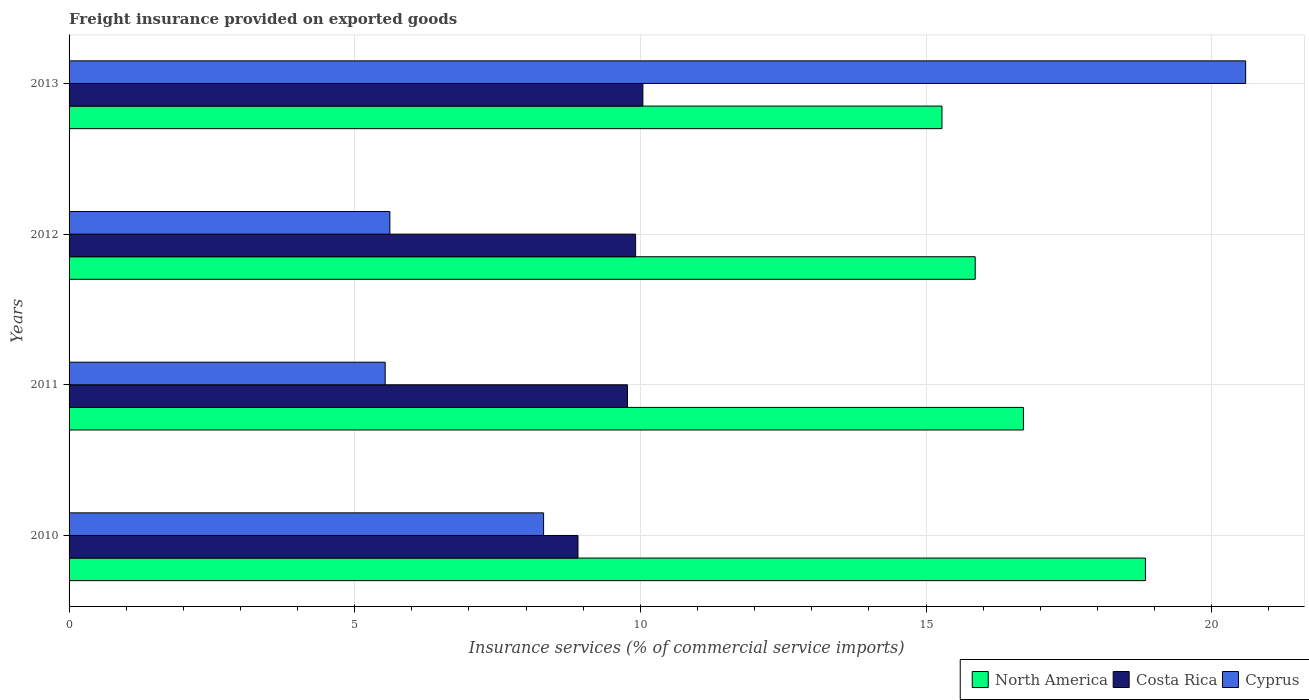How many different coloured bars are there?
Your answer should be compact. 3. How many groups of bars are there?
Provide a short and direct response. 4. How many bars are there on the 2nd tick from the top?
Provide a succinct answer. 3. How many bars are there on the 2nd tick from the bottom?
Ensure brevity in your answer.  3. What is the label of the 1st group of bars from the top?
Offer a very short reply. 2013. In how many cases, is the number of bars for a given year not equal to the number of legend labels?
Provide a succinct answer. 0. What is the freight insurance provided on exported goods in Costa Rica in 2012?
Give a very brief answer. 9.92. Across all years, what is the maximum freight insurance provided on exported goods in North America?
Keep it short and to the point. 18.84. Across all years, what is the minimum freight insurance provided on exported goods in Costa Rica?
Your response must be concise. 8.91. In which year was the freight insurance provided on exported goods in North America minimum?
Ensure brevity in your answer.  2013. What is the total freight insurance provided on exported goods in Cyprus in the graph?
Your answer should be very brief. 40.05. What is the difference between the freight insurance provided on exported goods in North America in 2010 and that in 2013?
Provide a succinct answer. 3.56. What is the difference between the freight insurance provided on exported goods in North America in 2011 and the freight insurance provided on exported goods in Cyprus in 2013?
Provide a short and direct response. -3.89. What is the average freight insurance provided on exported goods in Cyprus per year?
Your response must be concise. 10.01. In the year 2010, what is the difference between the freight insurance provided on exported goods in Costa Rica and freight insurance provided on exported goods in North America?
Your response must be concise. -9.93. What is the ratio of the freight insurance provided on exported goods in Costa Rica in 2011 to that in 2013?
Provide a short and direct response. 0.97. What is the difference between the highest and the second highest freight insurance provided on exported goods in Cyprus?
Make the answer very short. 12.29. What is the difference between the highest and the lowest freight insurance provided on exported goods in Cyprus?
Provide a succinct answer. 15.06. In how many years, is the freight insurance provided on exported goods in Costa Rica greater than the average freight insurance provided on exported goods in Costa Rica taken over all years?
Provide a succinct answer. 3. What does the 1st bar from the top in 2010 represents?
Your answer should be compact. Cyprus. What does the 2nd bar from the bottom in 2013 represents?
Your answer should be compact. Costa Rica. Are all the bars in the graph horizontal?
Ensure brevity in your answer.  Yes. Does the graph contain any zero values?
Make the answer very short. No. What is the title of the graph?
Keep it short and to the point. Freight insurance provided on exported goods. Does "China" appear as one of the legend labels in the graph?
Your answer should be very brief. No. What is the label or title of the X-axis?
Give a very brief answer. Insurance services (% of commercial service imports). What is the Insurance services (% of commercial service imports) of North America in 2010?
Keep it short and to the point. 18.84. What is the Insurance services (% of commercial service imports) in Costa Rica in 2010?
Provide a short and direct response. 8.91. What is the Insurance services (% of commercial service imports) of Cyprus in 2010?
Ensure brevity in your answer.  8.31. What is the Insurance services (% of commercial service imports) in North America in 2011?
Your answer should be compact. 16.7. What is the Insurance services (% of commercial service imports) of Costa Rica in 2011?
Offer a very short reply. 9.77. What is the Insurance services (% of commercial service imports) in Cyprus in 2011?
Your response must be concise. 5.53. What is the Insurance services (% of commercial service imports) of North America in 2012?
Your answer should be compact. 15.86. What is the Insurance services (% of commercial service imports) of Costa Rica in 2012?
Give a very brief answer. 9.92. What is the Insurance services (% of commercial service imports) in Cyprus in 2012?
Offer a terse response. 5.62. What is the Insurance services (% of commercial service imports) of North America in 2013?
Give a very brief answer. 15.28. What is the Insurance services (% of commercial service imports) in Costa Rica in 2013?
Provide a succinct answer. 10.04. What is the Insurance services (% of commercial service imports) of Cyprus in 2013?
Ensure brevity in your answer.  20.59. Across all years, what is the maximum Insurance services (% of commercial service imports) of North America?
Make the answer very short. 18.84. Across all years, what is the maximum Insurance services (% of commercial service imports) of Costa Rica?
Your answer should be very brief. 10.04. Across all years, what is the maximum Insurance services (% of commercial service imports) in Cyprus?
Ensure brevity in your answer.  20.59. Across all years, what is the minimum Insurance services (% of commercial service imports) in North America?
Give a very brief answer. 15.28. Across all years, what is the minimum Insurance services (% of commercial service imports) of Costa Rica?
Ensure brevity in your answer.  8.91. Across all years, what is the minimum Insurance services (% of commercial service imports) of Cyprus?
Ensure brevity in your answer.  5.53. What is the total Insurance services (% of commercial service imports) of North America in the graph?
Offer a very short reply. 66.68. What is the total Insurance services (% of commercial service imports) of Costa Rica in the graph?
Offer a very short reply. 38.64. What is the total Insurance services (% of commercial service imports) in Cyprus in the graph?
Offer a very short reply. 40.05. What is the difference between the Insurance services (% of commercial service imports) of North America in 2010 and that in 2011?
Your answer should be compact. 2.13. What is the difference between the Insurance services (% of commercial service imports) of Costa Rica in 2010 and that in 2011?
Offer a terse response. -0.87. What is the difference between the Insurance services (% of commercial service imports) of Cyprus in 2010 and that in 2011?
Ensure brevity in your answer.  2.77. What is the difference between the Insurance services (% of commercial service imports) in North America in 2010 and that in 2012?
Your answer should be very brief. 2.98. What is the difference between the Insurance services (% of commercial service imports) of Costa Rica in 2010 and that in 2012?
Your response must be concise. -1.01. What is the difference between the Insurance services (% of commercial service imports) in Cyprus in 2010 and that in 2012?
Ensure brevity in your answer.  2.69. What is the difference between the Insurance services (% of commercial service imports) of North America in 2010 and that in 2013?
Provide a short and direct response. 3.56. What is the difference between the Insurance services (% of commercial service imports) in Costa Rica in 2010 and that in 2013?
Your answer should be compact. -1.14. What is the difference between the Insurance services (% of commercial service imports) of Cyprus in 2010 and that in 2013?
Provide a short and direct response. -12.29. What is the difference between the Insurance services (% of commercial service imports) in North America in 2011 and that in 2012?
Give a very brief answer. 0.84. What is the difference between the Insurance services (% of commercial service imports) in Costa Rica in 2011 and that in 2012?
Offer a terse response. -0.14. What is the difference between the Insurance services (% of commercial service imports) of Cyprus in 2011 and that in 2012?
Provide a short and direct response. -0.08. What is the difference between the Insurance services (% of commercial service imports) of North America in 2011 and that in 2013?
Provide a short and direct response. 1.43. What is the difference between the Insurance services (% of commercial service imports) of Costa Rica in 2011 and that in 2013?
Make the answer very short. -0.27. What is the difference between the Insurance services (% of commercial service imports) in Cyprus in 2011 and that in 2013?
Ensure brevity in your answer.  -15.06. What is the difference between the Insurance services (% of commercial service imports) of North America in 2012 and that in 2013?
Ensure brevity in your answer.  0.58. What is the difference between the Insurance services (% of commercial service imports) of Costa Rica in 2012 and that in 2013?
Your response must be concise. -0.13. What is the difference between the Insurance services (% of commercial service imports) of Cyprus in 2012 and that in 2013?
Offer a terse response. -14.98. What is the difference between the Insurance services (% of commercial service imports) of North America in 2010 and the Insurance services (% of commercial service imports) of Costa Rica in 2011?
Your answer should be very brief. 9.07. What is the difference between the Insurance services (% of commercial service imports) in North America in 2010 and the Insurance services (% of commercial service imports) in Cyprus in 2011?
Your answer should be very brief. 13.31. What is the difference between the Insurance services (% of commercial service imports) in Costa Rica in 2010 and the Insurance services (% of commercial service imports) in Cyprus in 2011?
Give a very brief answer. 3.37. What is the difference between the Insurance services (% of commercial service imports) in North America in 2010 and the Insurance services (% of commercial service imports) in Costa Rica in 2012?
Ensure brevity in your answer.  8.92. What is the difference between the Insurance services (% of commercial service imports) in North America in 2010 and the Insurance services (% of commercial service imports) in Cyprus in 2012?
Give a very brief answer. 13.22. What is the difference between the Insurance services (% of commercial service imports) of Costa Rica in 2010 and the Insurance services (% of commercial service imports) of Cyprus in 2012?
Give a very brief answer. 3.29. What is the difference between the Insurance services (% of commercial service imports) in North America in 2010 and the Insurance services (% of commercial service imports) in Costa Rica in 2013?
Provide a short and direct response. 8.8. What is the difference between the Insurance services (% of commercial service imports) in North America in 2010 and the Insurance services (% of commercial service imports) in Cyprus in 2013?
Make the answer very short. -1.75. What is the difference between the Insurance services (% of commercial service imports) in Costa Rica in 2010 and the Insurance services (% of commercial service imports) in Cyprus in 2013?
Provide a succinct answer. -11.69. What is the difference between the Insurance services (% of commercial service imports) of North America in 2011 and the Insurance services (% of commercial service imports) of Costa Rica in 2012?
Your answer should be very brief. 6.79. What is the difference between the Insurance services (% of commercial service imports) of North America in 2011 and the Insurance services (% of commercial service imports) of Cyprus in 2012?
Offer a terse response. 11.09. What is the difference between the Insurance services (% of commercial service imports) in Costa Rica in 2011 and the Insurance services (% of commercial service imports) in Cyprus in 2012?
Give a very brief answer. 4.16. What is the difference between the Insurance services (% of commercial service imports) in North America in 2011 and the Insurance services (% of commercial service imports) in Costa Rica in 2013?
Your answer should be very brief. 6.66. What is the difference between the Insurance services (% of commercial service imports) in North America in 2011 and the Insurance services (% of commercial service imports) in Cyprus in 2013?
Your response must be concise. -3.89. What is the difference between the Insurance services (% of commercial service imports) of Costa Rica in 2011 and the Insurance services (% of commercial service imports) of Cyprus in 2013?
Provide a short and direct response. -10.82. What is the difference between the Insurance services (% of commercial service imports) in North America in 2012 and the Insurance services (% of commercial service imports) in Costa Rica in 2013?
Provide a short and direct response. 5.82. What is the difference between the Insurance services (% of commercial service imports) in North America in 2012 and the Insurance services (% of commercial service imports) in Cyprus in 2013?
Provide a succinct answer. -4.73. What is the difference between the Insurance services (% of commercial service imports) in Costa Rica in 2012 and the Insurance services (% of commercial service imports) in Cyprus in 2013?
Offer a very short reply. -10.68. What is the average Insurance services (% of commercial service imports) in North America per year?
Make the answer very short. 16.67. What is the average Insurance services (% of commercial service imports) in Costa Rica per year?
Ensure brevity in your answer.  9.66. What is the average Insurance services (% of commercial service imports) of Cyprus per year?
Your response must be concise. 10.01. In the year 2010, what is the difference between the Insurance services (% of commercial service imports) of North America and Insurance services (% of commercial service imports) of Costa Rica?
Give a very brief answer. 9.93. In the year 2010, what is the difference between the Insurance services (% of commercial service imports) of North America and Insurance services (% of commercial service imports) of Cyprus?
Your answer should be very brief. 10.53. In the year 2010, what is the difference between the Insurance services (% of commercial service imports) in Costa Rica and Insurance services (% of commercial service imports) in Cyprus?
Offer a very short reply. 0.6. In the year 2011, what is the difference between the Insurance services (% of commercial service imports) in North America and Insurance services (% of commercial service imports) in Costa Rica?
Provide a short and direct response. 6.93. In the year 2011, what is the difference between the Insurance services (% of commercial service imports) of North America and Insurance services (% of commercial service imports) of Cyprus?
Your answer should be very brief. 11.17. In the year 2011, what is the difference between the Insurance services (% of commercial service imports) of Costa Rica and Insurance services (% of commercial service imports) of Cyprus?
Your response must be concise. 4.24. In the year 2012, what is the difference between the Insurance services (% of commercial service imports) of North America and Insurance services (% of commercial service imports) of Costa Rica?
Your answer should be compact. 5.94. In the year 2012, what is the difference between the Insurance services (% of commercial service imports) in North America and Insurance services (% of commercial service imports) in Cyprus?
Give a very brief answer. 10.24. In the year 2012, what is the difference between the Insurance services (% of commercial service imports) in Costa Rica and Insurance services (% of commercial service imports) in Cyprus?
Offer a very short reply. 4.3. In the year 2013, what is the difference between the Insurance services (% of commercial service imports) in North America and Insurance services (% of commercial service imports) in Costa Rica?
Provide a succinct answer. 5.23. In the year 2013, what is the difference between the Insurance services (% of commercial service imports) of North America and Insurance services (% of commercial service imports) of Cyprus?
Your answer should be very brief. -5.32. In the year 2013, what is the difference between the Insurance services (% of commercial service imports) in Costa Rica and Insurance services (% of commercial service imports) in Cyprus?
Your response must be concise. -10.55. What is the ratio of the Insurance services (% of commercial service imports) in North America in 2010 to that in 2011?
Your answer should be compact. 1.13. What is the ratio of the Insurance services (% of commercial service imports) in Costa Rica in 2010 to that in 2011?
Your answer should be very brief. 0.91. What is the ratio of the Insurance services (% of commercial service imports) of Cyprus in 2010 to that in 2011?
Your response must be concise. 1.5. What is the ratio of the Insurance services (% of commercial service imports) in North America in 2010 to that in 2012?
Ensure brevity in your answer.  1.19. What is the ratio of the Insurance services (% of commercial service imports) of Costa Rica in 2010 to that in 2012?
Ensure brevity in your answer.  0.9. What is the ratio of the Insurance services (% of commercial service imports) of Cyprus in 2010 to that in 2012?
Provide a succinct answer. 1.48. What is the ratio of the Insurance services (% of commercial service imports) of North America in 2010 to that in 2013?
Offer a terse response. 1.23. What is the ratio of the Insurance services (% of commercial service imports) of Costa Rica in 2010 to that in 2013?
Keep it short and to the point. 0.89. What is the ratio of the Insurance services (% of commercial service imports) in Cyprus in 2010 to that in 2013?
Your response must be concise. 0.4. What is the ratio of the Insurance services (% of commercial service imports) of North America in 2011 to that in 2012?
Offer a very short reply. 1.05. What is the ratio of the Insurance services (% of commercial service imports) in Costa Rica in 2011 to that in 2012?
Ensure brevity in your answer.  0.99. What is the ratio of the Insurance services (% of commercial service imports) of North America in 2011 to that in 2013?
Ensure brevity in your answer.  1.09. What is the ratio of the Insurance services (% of commercial service imports) of Costa Rica in 2011 to that in 2013?
Give a very brief answer. 0.97. What is the ratio of the Insurance services (% of commercial service imports) in Cyprus in 2011 to that in 2013?
Your answer should be compact. 0.27. What is the ratio of the Insurance services (% of commercial service imports) of North America in 2012 to that in 2013?
Make the answer very short. 1.04. What is the ratio of the Insurance services (% of commercial service imports) of Costa Rica in 2012 to that in 2013?
Your answer should be compact. 0.99. What is the ratio of the Insurance services (% of commercial service imports) of Cyprus in 2012 to that in 2013?
Provide a succinct answer. 0.27. What is the difference between the highest and the second highest Insurance services (% of commercial service imports) in North America?
Provide a short and direct response. 2.13. What is the difference between the highest and the second highest Insurance services (% of commercial service imports) in Costa Rica?
Offer a very short reply. 0.13. What is the difference between the highest and the second highest Insurance services (% of commercial service imports) of Cyprus?
Keep it short and to the point. 12.29. What is the difference between the highest and the lowest Insurance services (% of commercial service imports) in North America?
Provide a short and direct response. 3.56. What is the difference between the highest and the lowest Insurance services (% of commercial service imports) in Costa Rica?
Offer a very short reply. 1.14. What is the difference between the highest and the lowest Insurance services (% of commercial service imports) of Cyprus?
Offer a very short reply. 15.06. 